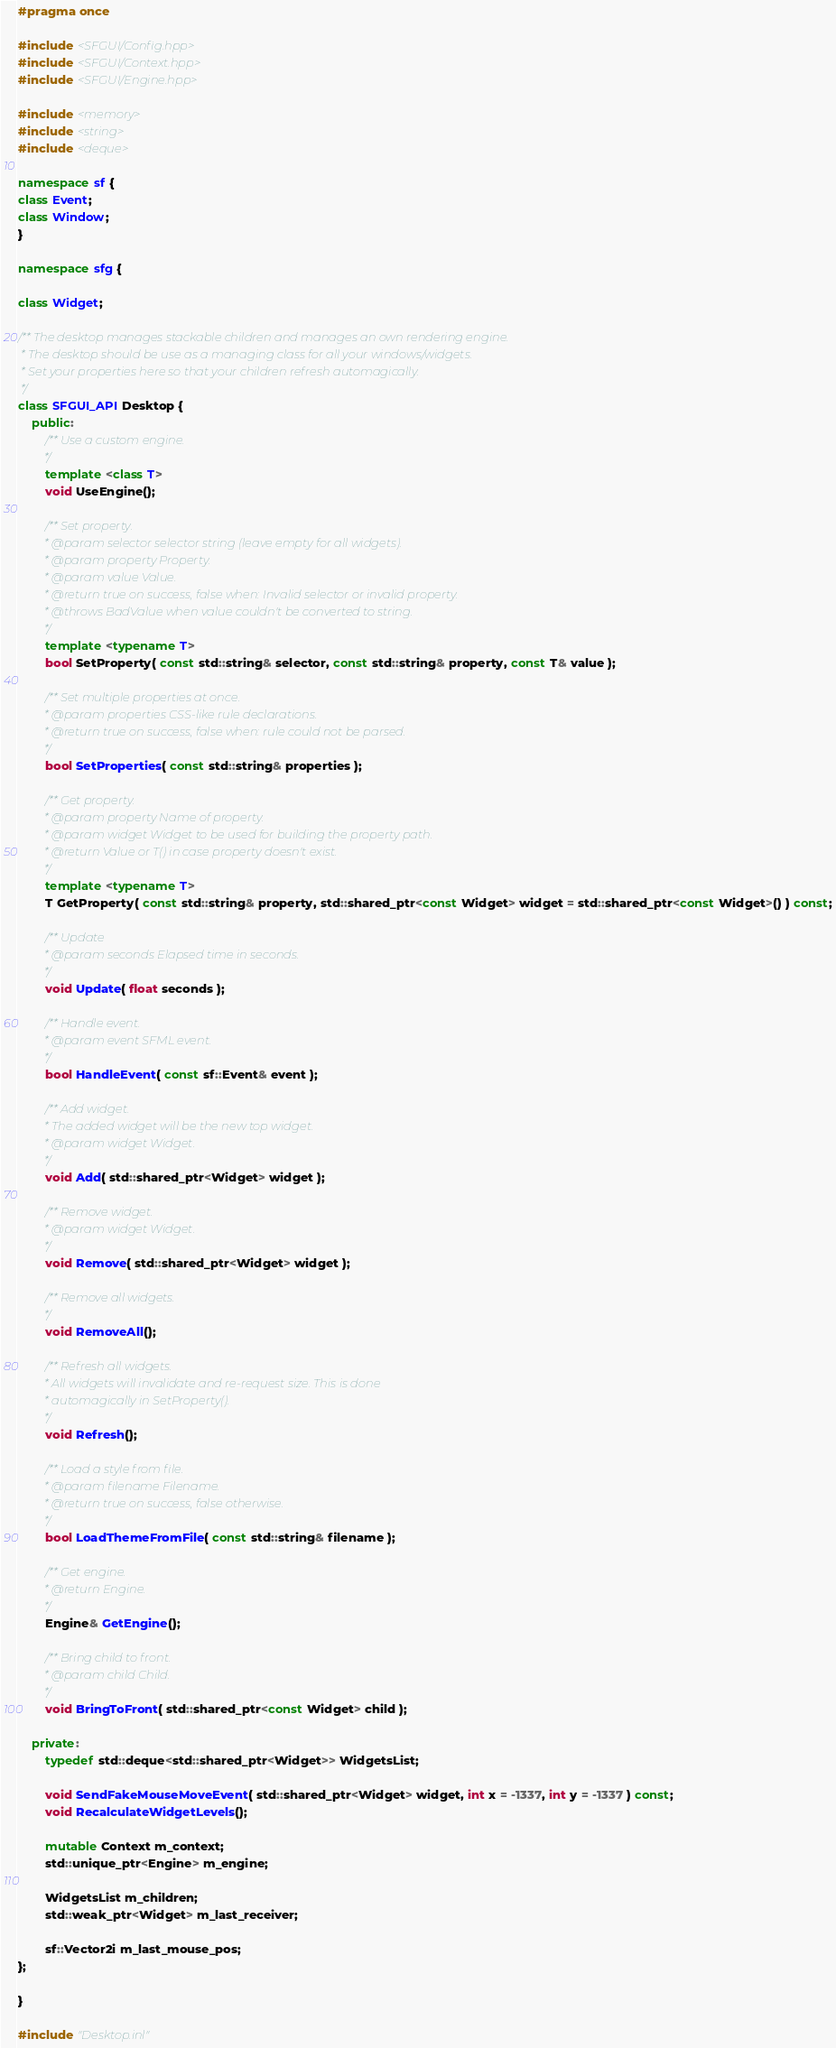<code> <loc_0><loc_0><loc_500><loc_500><_C++_>#pragma once

#include <SFGUI/Config.hpp>
#include <SFGUI/Context.hpp>
#include <SFGUI/Engine.hpp>

#include <memory>
#include <string>
#include <deque>

namespace sf {
class Event;
class Window;
}

namespace sfg {

class Widget;

/** The desktop manages stackable children and manages an own rendering engine.
 * The desktop should be use as a managing class for all your windows/widgets.
 * Set your properties here so that your children refresh automagically.
 */
class SFGUI_API Desktop {
	public:
		/** Use a custom engine.
		 */
		template <class T>
		void UseEngine();

		/** Set property.
		 * @param selector selector string (leave empty for all widgets).
		 * @param property Property.
		 * @param value Value.
		 * @return true on success, false when: Invalid selector or invalid property.
		 * @throws BadValue when value couldn't be converted to string.
		 */
		template <typename T>
		bool SetProperty( const std::string& selector, const std::string& property, const T& value );

		/** Set multiple properties at once.
		 * @param properties CSS-like rule declarations.
		 * @return true on success, false when: rule could not be parsed.
		 */
		bool SetProperties( const std::string& properties );

		/** Get property.
		 * @param property Name of property.
		 * @param widget Widget to be used for building the property path.
		 * @return Value or T() in case property doesn't exist.
		 */
		template <typename T>
		T GetProperty( const std::string& property, std::shared_ptr<const Widget> widget = std::shared_ptr<const Widget>() ) const;

		/** Update
		 * @param seconds Elapsed time in seconds.
		 */
		void Update( float seconds );

		/** Handle event.
		 * @param event SFML event.
		 */
		bool HandleEvent( const sf::Event& event );

		/** Add widget.
		 * The added widget will be the new top widget.
		 * @param widget Widget.
		 */
		void Add( std::shared_ptr<Widget> widget );

		/** Remove widget.
		 * @param widget Widget.
		 */
		void Remove( std::shared_ptr<Widget> widget );

		/** Remove all widgets.
		 */
		void RemoveAll();

		/** Refresh all widgets.
		 * All widgets will invalidate and re-request size. This is done
		 * automagically in SetProperty().
		 */
		void Refresh();

		/** Load a style from file.
		 * @param filename Filename.
		 * @return true on success, false otherwise.
		 */
		bool LoadThemeFromFile( const std::string& filename );

		/** Get engine.
		 * @return Engine.
		 */
		Engine& GetEngine();

		/** Bring child to front.
		 * @param child Child.
		 */
		void BringToFront( std::shared_ptr<const Widget> child );

	private:
		typedef std::deque<std::shared_ptr<Widget>> WidgetsList;

		void SendFakeMouseMoveEvent( std::shared_ptr<Widget> widget, int x = -1337, int y = -1337 ) const;
		void RecalculateWidgetLevels();

		mutable Context m_context;
		std::unique_ptr<Engine> m_engine;

		WidgetsList m_children;
		std::weak_ptr<Widget> m_last_receiver;

		sf::Vector2i m_last_mouse_pos;
};

}

#include "Desktop.inl"
</code> 